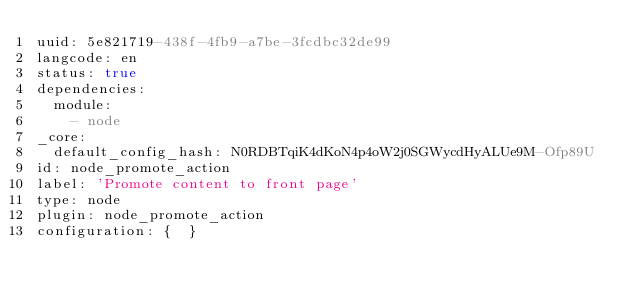<code> <loc_0><loc_0><loc_500><loc_500><_YAML_>uuid: 5e821719-438f-4fb9-a7be-3fcdbc32de99
langcode: en
status: true
dependencies:
  module:
    - node
_core:
  default_config_hash: N0RDBTqiK4dKoN4p4oW2j0SGWycdHyALUe9M-Ofp89U
id: node_promote_action
label: 'Promote content to front page'
type: node
plugin: node_promote_action
configuration: {  }
</code> 